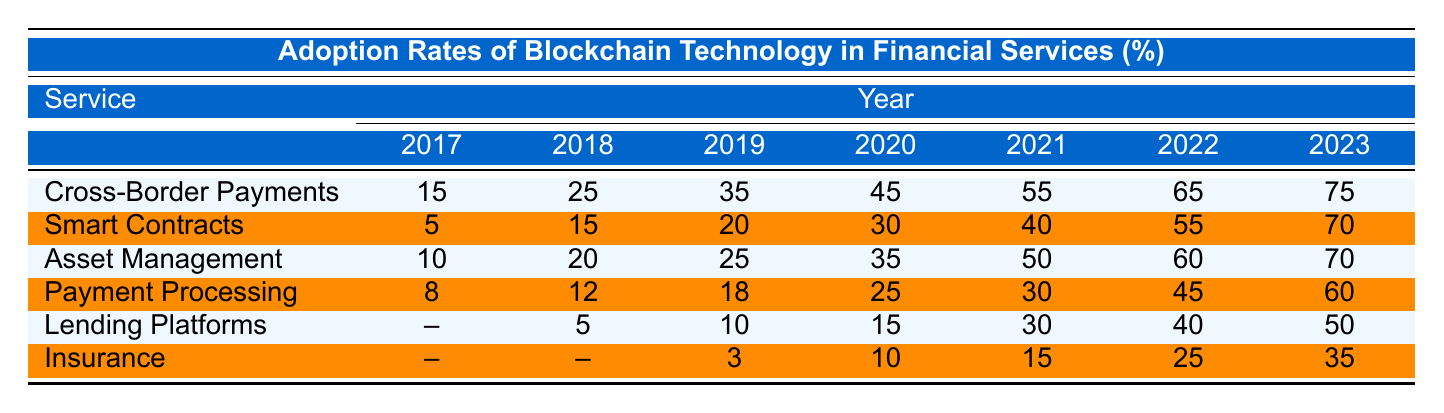What was the adoption rate of smart contracts in 2020? The table shows that the adoption rate of smart contracts in 2020 is listed as 30%.
Answer: 30 Which financial service had the highest adoption rate in 2023? In 2023, cross-border payments had the highest adoption rate at 75%.
Answer: 75 What was the difference in adoption rates for asset management between 2019 and 2021? The adoption rate for asset management in 2019 was 25%, and it rose to 50% in 2021. The difference is 50 - 25 = 25%.
Answer: 25 True or False: The adoption rate of insurance reached 50% in any of the years. Looking at the insurance adoption rates, the maximum recorded was 35% in 2023, which is below 50%. Therefore, the statement is false.
Answer: False What is the average adoption rate for payment processing from 2017 to 2023? The rates for payment processing are 8, 12, 18, 25, 30, 45, and 60. Adding these gives 8 + 12 + 18 + 25 + 30 + 45 + 60 = 198. There are 7 data points, so the average is 198 / 7 = approximately 28.29.
Answer: Approximately 28.29 In which year did lending platforms have their highest adoption rate, and what was that rate? Looking at the table, lending platforms have increased rates, with 50% in 2023 being the highest recorded.
Answer: 50 in 2023 How much did the adoption of cross-border payments grow from 2017 to 2022? The adoption rate for cross-border payments in 2017 was 15%, and it rose to 65% in 2022. The growth is calculated as 65 - 15 = 50%.
Answer: 50 What was the trend for the adoption rates of smart contracts from 2017 to 2023? The rates steadily increased from 5% in 2017 to 70% in 2023. This shows a continuous growth trend over the years.
Answer: Continuous growth What is the total adoption rate of blockchain technology in asset management from 2018 to 2023? The adoption rates for asset management from 2018 to 2023 are 20, 25, 35, 50, 60, and 70. Adding these gives 20 + 25 + 35 + 50 + 60 + 70 = 260%.
Answer: 260% Which financial service saw the least adoption in 2017 and what was the percentage? In 2017, both lending platforms and insurance had no recorded adoption rate, represented as null. Thus, they had the least.
Answer: Lending platforms and insurance (null) 